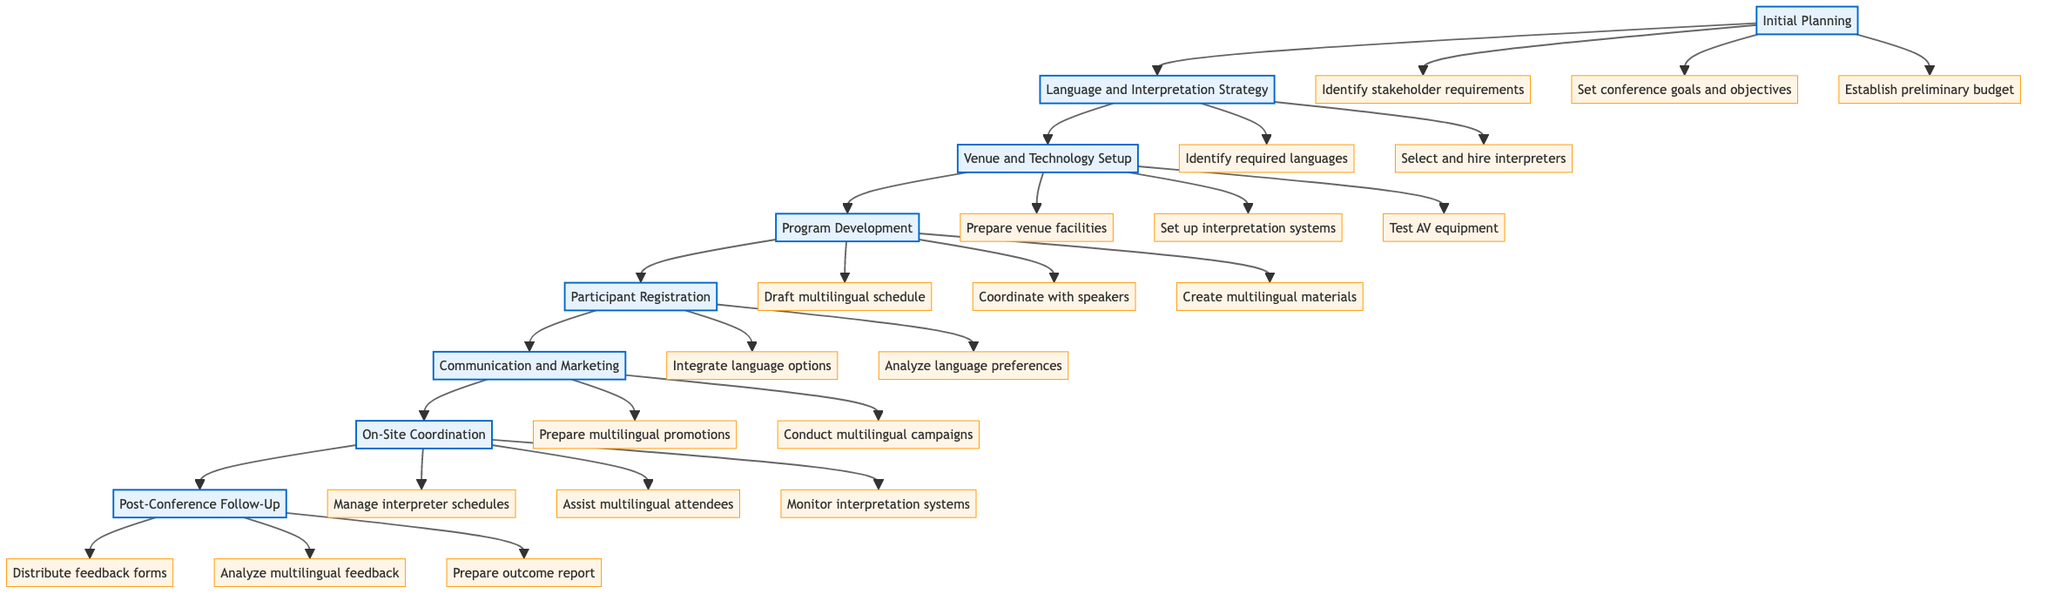What is the first step in the workflow? The diagram specifies that "Initial Planning" is the first step in the workflow leading to the coordination of the conference, as it starts at the top of the flowchart.
Answer: Initial Planning How many actions are associated with the "On-Site Coordination" step? By examining the "On-Site Coordination" node, we can see that there are three actions linked to it: manage interpreter schedules, assist multilingual attendees, and monitor interpretation systems.
Answer: 3 List one action in the "Language and Interpretation Strategy" step. The "Language and Interpretation Strategy" step includes two actions, one of which is "Identify required languages based on participant demographics." This can be chosen as an example action from that step.
Answer: Identify required languages What follows the "Participant Registration" step in the workflow? The flowchart indicates that the step following "Participant Registration" is "Communication and Marketing," as indicated by the directed arrow leading from one node to the next.
Answer: Communication and Marketing Which step includes creating bilingual/multilingual presentation materials? Looking at the "Program Development" step in the diagram reveals that one of its actions is "Create bilingual/multilingual presentation materials."
Answer: Program Development Which action is a part of the "Post-Conference Follow-Up" step? By checking the "Post-Conference Follow-Up" step, we find several actions, including "Distribute multilingual feedback forms" as one of its key actions.
Answer: Distribute multilingual feedback forms What is the total number of steps in the workflow? By counting the steps represented as nodes in the flowchart, we can find that there are a total of eight main steps involved in the workflow for the conference.
Answer: 8 How many total actions are described across all steps in the workflow? If we sum the number of actions detailed under each step in the workflow, we find that there are 20 actions connected overall, indicating the extensive details required for coordination.
Answer: 20 What is the last step in the workflow? The final step in the workflow, as shown at the bottom of the diagram, is "Post-Conference Follow-Up," marking the conclusion of the planning and execution process.
Answer: Post-Conference Follow-Up 